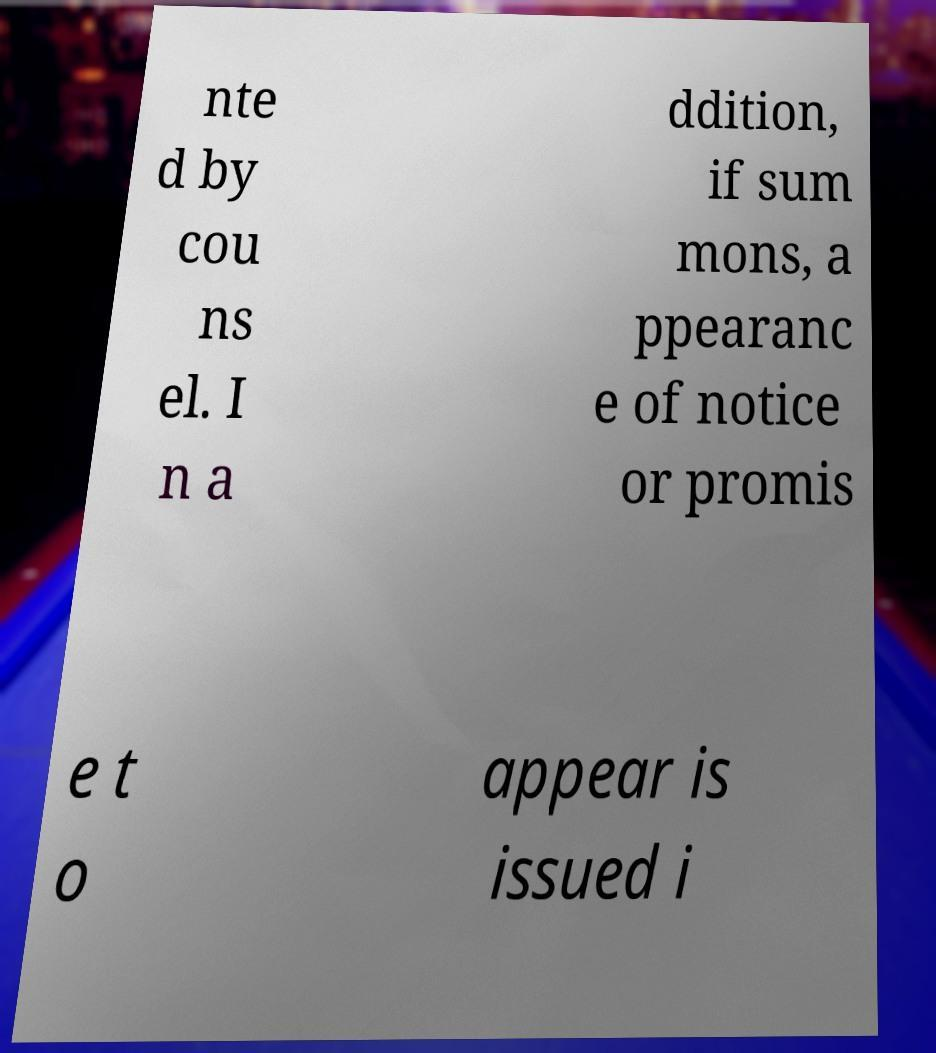There's text embedded in this image that I need extracted. Can you transcribe it verbatim? nte d by cou ns el. I n a ddition, if sum mons, a ppearanc e of notice or promis e t o appear is issued i 